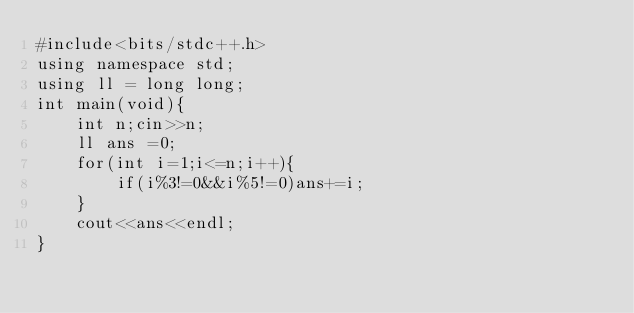Convert code to text. <code><loc_0><loc_0><loc_500><loc_500><_C_>#include<bits/stdc++.h>
using namespace std;
using ll = long long;
int main(void){
    int n;cin>>n;
    ll ans =0;
    for(int i=1;i<=n;i++){
        if(i%3!=0&&i%5!=0)ans+=i;
    }
    cout<<ans<<endl;
}</code> 